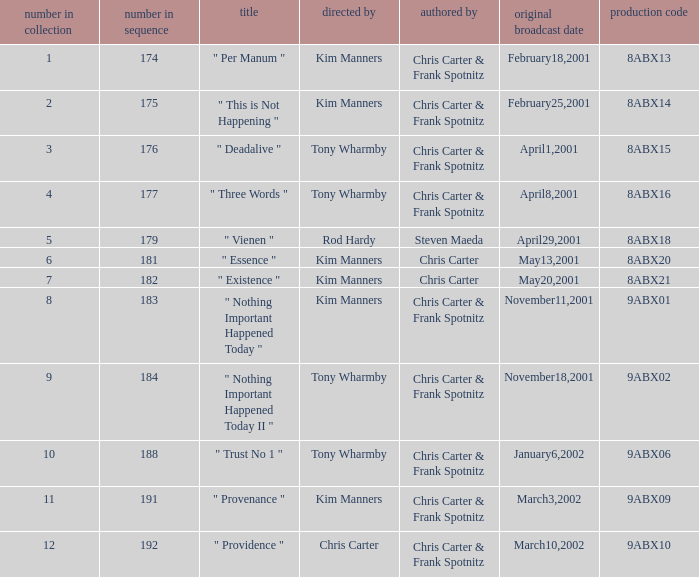What is the episode number that has production code 8abx15? 176.0. 